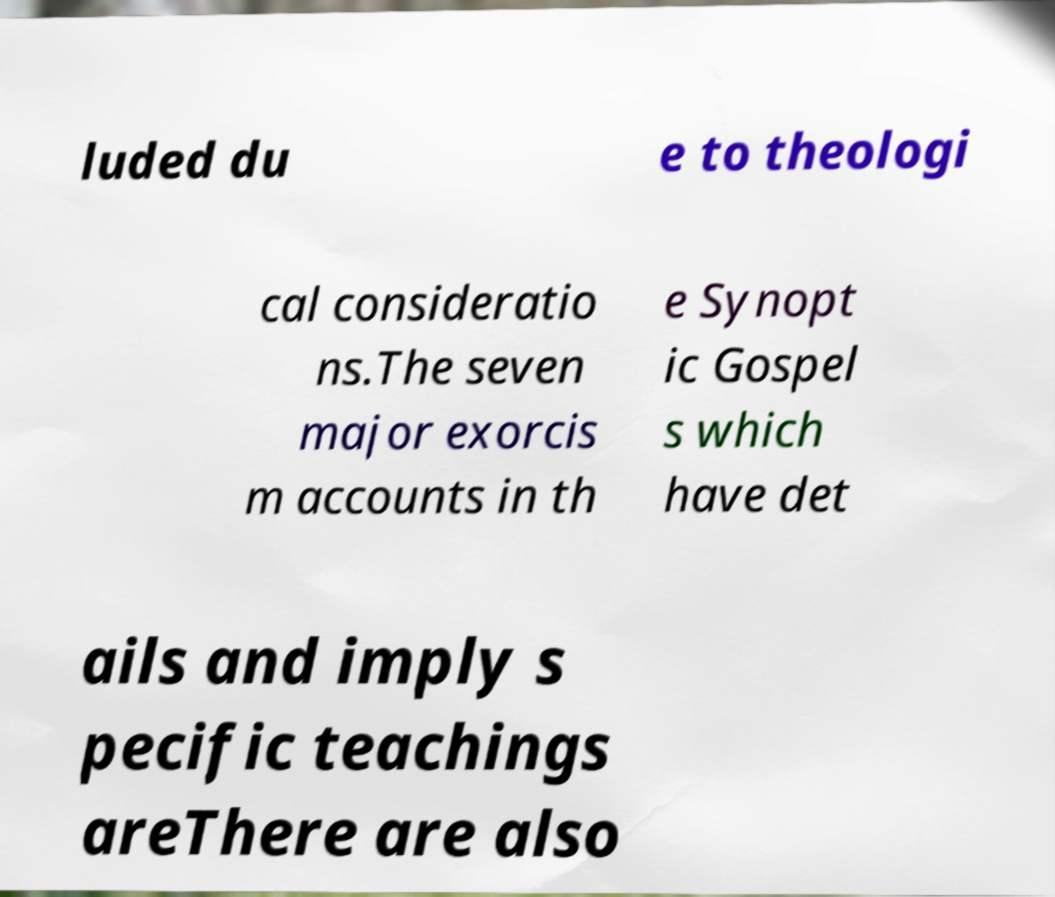Please read and relay the text visible in this image. What does it say? luded du e to theologi cal consideratio ns.The seven major exorcis m accounts in th e Synopt ic Gospel s which have det ails and imply s pecific teachings areThere are also 